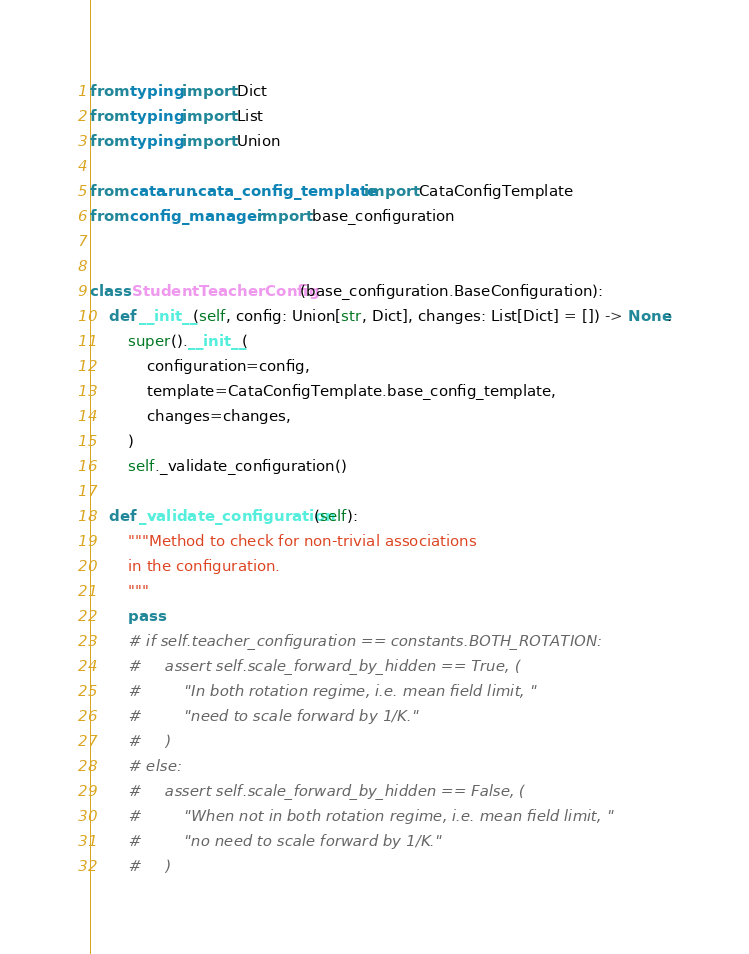<code> <loc_0><loc_0><loc_500><loc_500><_Python_>from typing import Dict
from typing import List
from typing import Union

from cata.run.cata_config_template import CataConfigTemplate
from config_manager import base_configuration


class StudentTeacherConfig(base_configuration.BaseConfiguration):
    def __init__(self, config: Union[str, Dict], changes: List[Dict] = []) -> None:
        super().__init__(
            configuration=config,
            template=CataConfigTemplate.base_config_template,
            changes=changes,
        )
        self._validate_configuration()

    def _validate_configuration(self):
        """Method to check for non-trivial associations
        in the configuration.
        """
        pass
        # if self.teacher_configuration == constants.BOTH_ROTATION:
        #     assert self.scale_forward_by_hidden == True, (
        #         "In both rotation regime, i.e. mean field limit, "
        #         "need to scale forward by 1/K."
        #     )
        # else:
        #     assert self.scale_forward_by_hidden == False, (
        #         "When not in both rotation regime, i.e. mean field limit, "
        #         "no need to scale forward by 1/K."
        #     )
</code> 